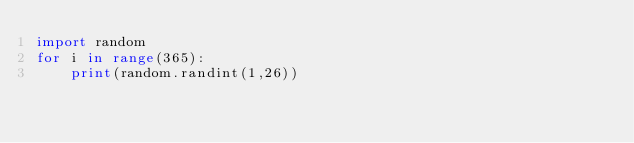<code> <loc_0><loc_0><loc_500><loc_500><_Python_>import random
for i in range(365):
    print(random.randint(1,26))</code> 